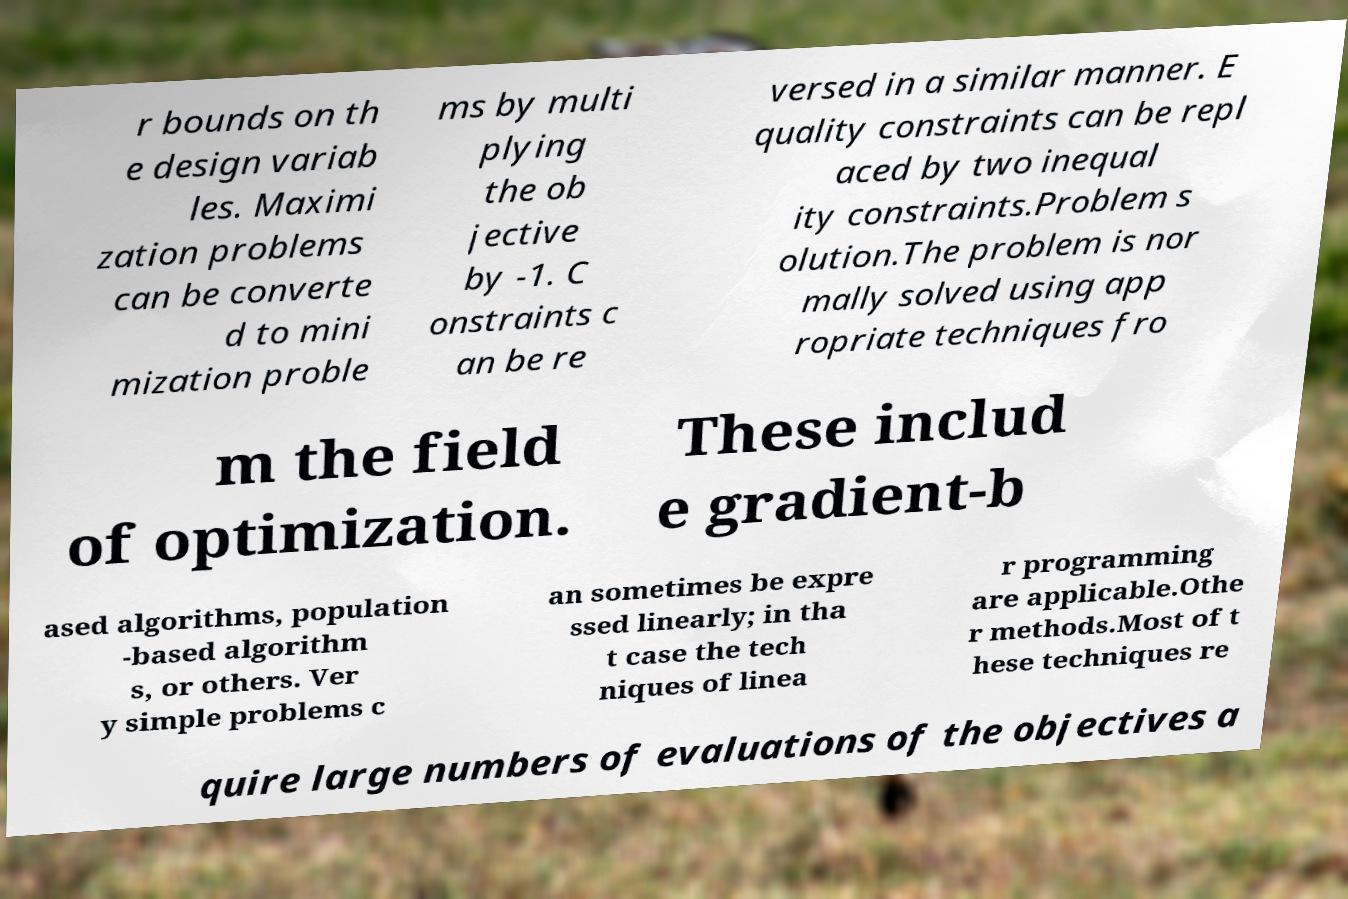Please read and relay the text visible in this image. What does it say? r bounds on th e design variab les. Maximi zation problems can be converte d to mini mization proble ms by multi plying the ob jective by -1. C onstraints c an be re versed in a similar manner. E quality constraints can be repl aced by two inequal ity constraints.Problem s olution.The problem is nor mally solved using app ropriate techniques fro m the field of optimization. These includ e gradient-b ased algorithms, population -based algorithm s, or others. Ver y simple problems c an sometimes be expre ssed linearly; in tha t case the tech niques of linea r programming are applicable.Othe r methods.Most of t hese techniques re quire large numbers of evaluations of the objectives a 